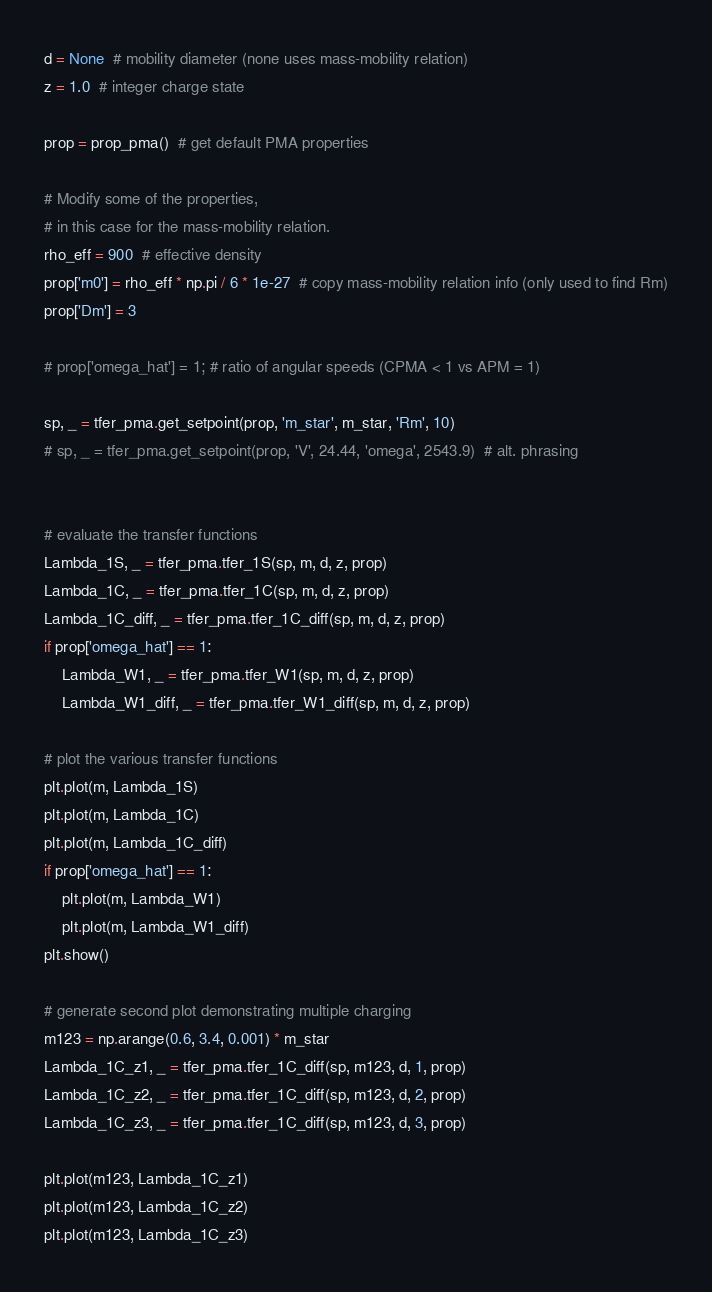<code> <loc_0><loc_0><loc_500><loc_500><_Python_>d = None  # mobility diameter (none uses mass-mobility relation)
z = 1.0  # integer charge state

prop = prop_pma()  # get default PMA properties

# Modify some of the properties,
# in this case for the mass-mobility relation.
rho_eff = 900  # effective density
prop['m0'] = rho_eff * np.pi / 6 * 1e-27  # copy mass-mobility relation info (only used to find Rm)
prop['Dm'] = 3

# prop['omega_hat'] = 1; # ratio of angular speeds (CPMA < 1 vs APM = 1)

sp, _ = tfer_pma.get_setpoint(prop, 'm_star', m_star, 'Rm', 10)
# sp, _ = tfer_pma.get_setpoint(prop, 'V', 24.44, 'omega', 2543.9)  # alt. phrasing


# evaluate the transfer functions
Lambda_1S, _ = tfer_pma.tfer_1S(sp, m, d, z, prop)
Lambda_1C, _ = tfer_pma.tfer_1C(sp, m, d, z, prop)
Lambda_1C_diff, _ = tfer_pma.tfer_1C_diff(sp, m, d, z, prop)
if prop['omega_hat'] == 1:
    Lambda_W1, _ = tfer_pma.tfer_W1(sp, m, d, z, prop)
    Lambda_W1_diff, _ = tfer_pma.tfer_W1_diff(sp, m, d, z, prop)

# plot the various transfer functions
plt.plot(m, Lambda_1S)
plt.plot(m, Lambda_1C)
plt.plot(m, Lambda_1C_diff)
if prop['omega_hat'] == 1:
    plt.plot(m, Lambda_W1)
    plt.plot(m, Lambda_W1_diff)
plt.show()

# generate second plot demonstrating multiple charging
m123 = np.arange(0.6, 3.4, 0.001) * m_star
Lambda_1C_z1, _ = tfer_pma.tfer_1C_diff(sp, m123, d, 1, prop)
Lambda_1C_z2, _ = tfer_pma.tfer_1C_diff(sp, m123, d, 2, prop)
Lambda_1C_z3, _ = tfer_pma.tfer_1C_diff(sp, m123, d, 3, prop)

plt.plot(m123, Lambda_1C_z1)
plt.plot(m123, Lambda_1C_z2)
plt.plot(m123, Lambda_1C_z3)</code> 